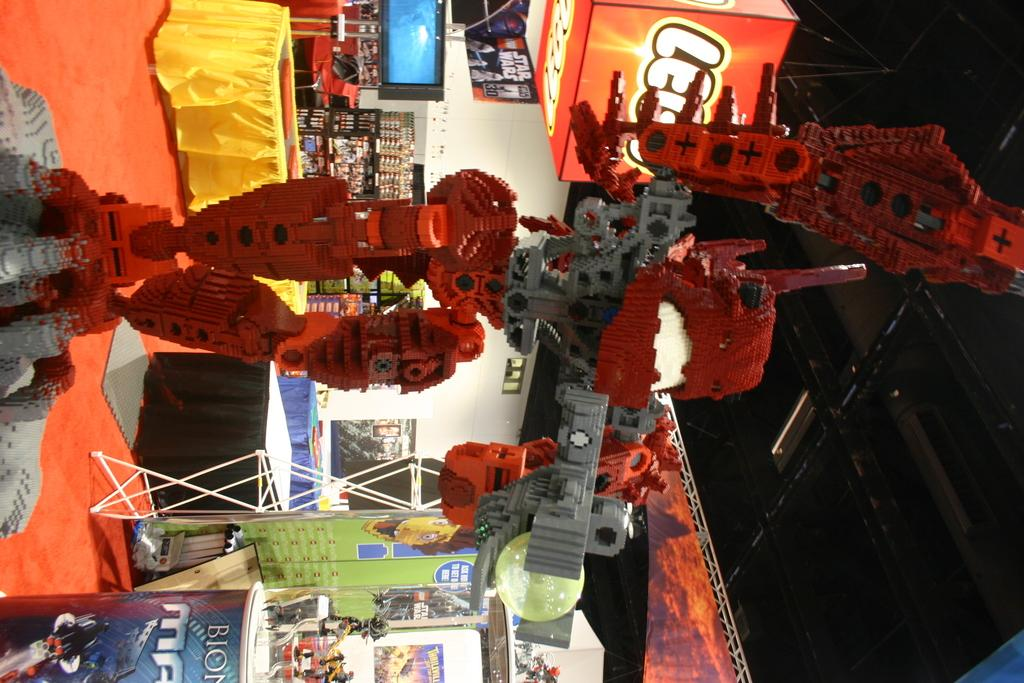What is the main subject in the center of the image? There is a robot in the center of the image. What can be seen in the background of the image? There are stalls in the background of the image. What is at the bottom of the image? There is a carpet at the bottom of the image. What is at the top of the image? There is a ceiling at the top of the image. What type of effect does the robot have on the sky in the image? There is no sky present in the image, as it features a ceiling at the top. 